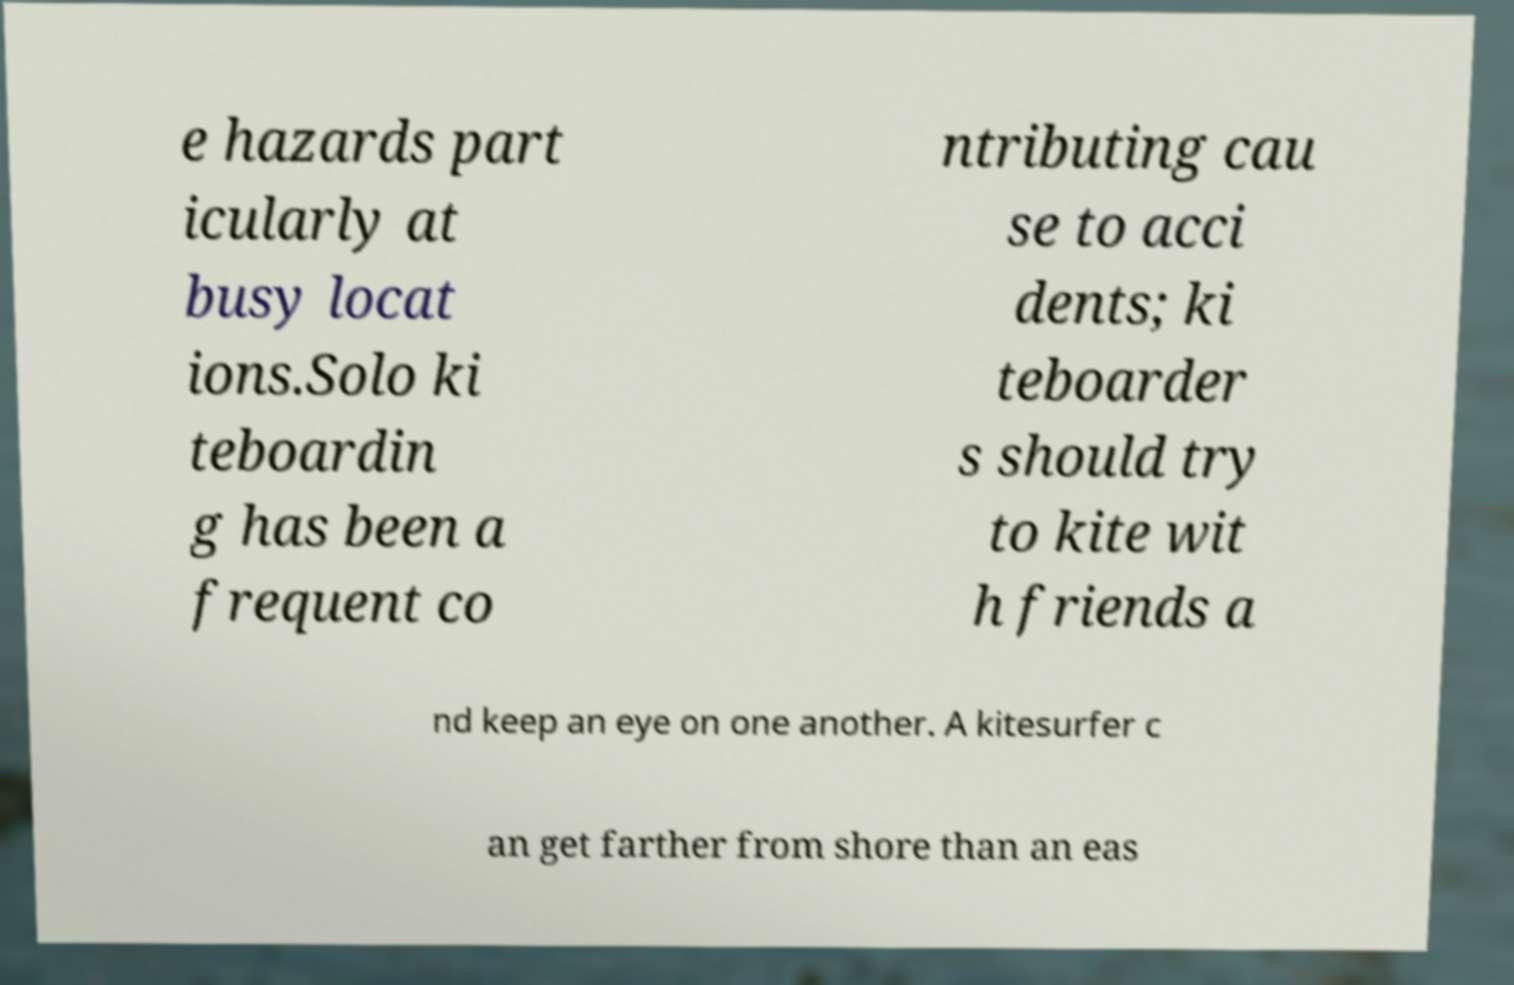There's text embedded in this image that I need extracted. Can you transcribe it verbatim? e hazards part icularly at busy locat ions.Solo ki teboardin g has been a frequent co ntributing cau se to acci dents; ki teboarder s should try to kite wit h friends a nd keep an eye on one another. A kitesurfer c an get farther from shore than an eas 